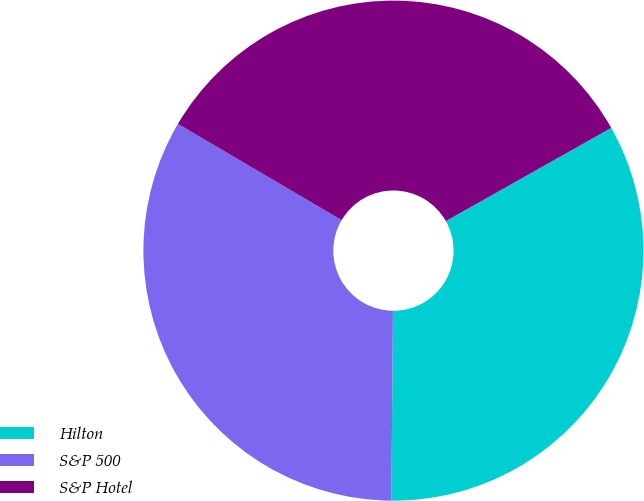<chart> <loc_0><loc_0><loc_500><loc_500><pie_chart><fcel>Hilton<fcel>S&P 500<fcel>S&P Hotel<nl><fcel>33.3%<fcel>33.33%<fcel>33.37%<nl></chart> 